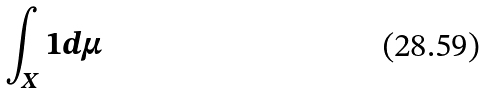<formula> <loc_0><loc_0><loc_500><loc_500>\int _ { X } 1 d \mu</formula> 